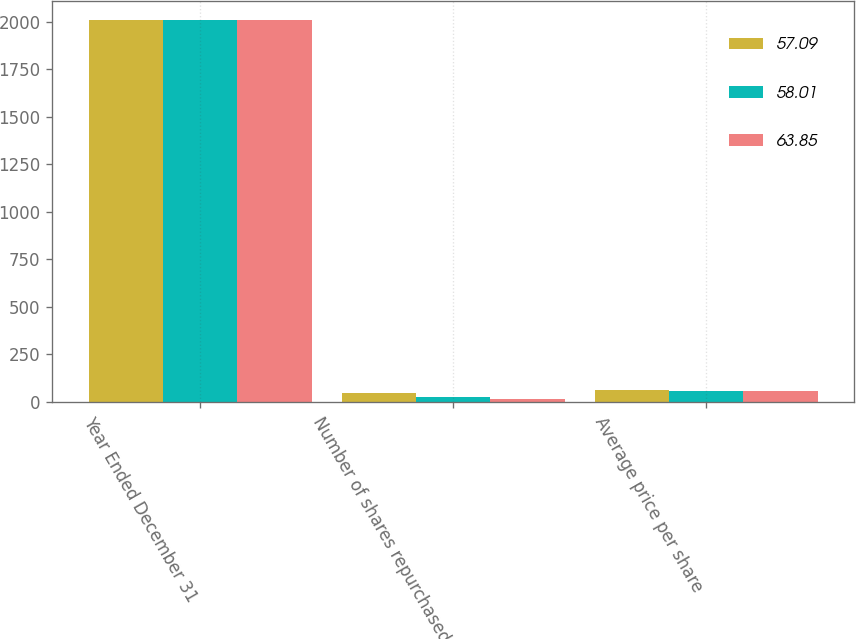Convert chart. <chart><loc_0><loc_0><loc_500><loc_500><stacked_bar_chart><ecel><fcel>Year Ended December 31<fcel>Number of shares repurchased<fcel>Average price per share<nl><fcel>57.09<fcel>2010<fcel>49<fcel>63.85<nl><fcel>58.01<fcel>2009<fcel>26<fcel>57.09<nl><fcel>63.85<fcel>2008<fcel>18<fcel>58.01<nl></chart> 